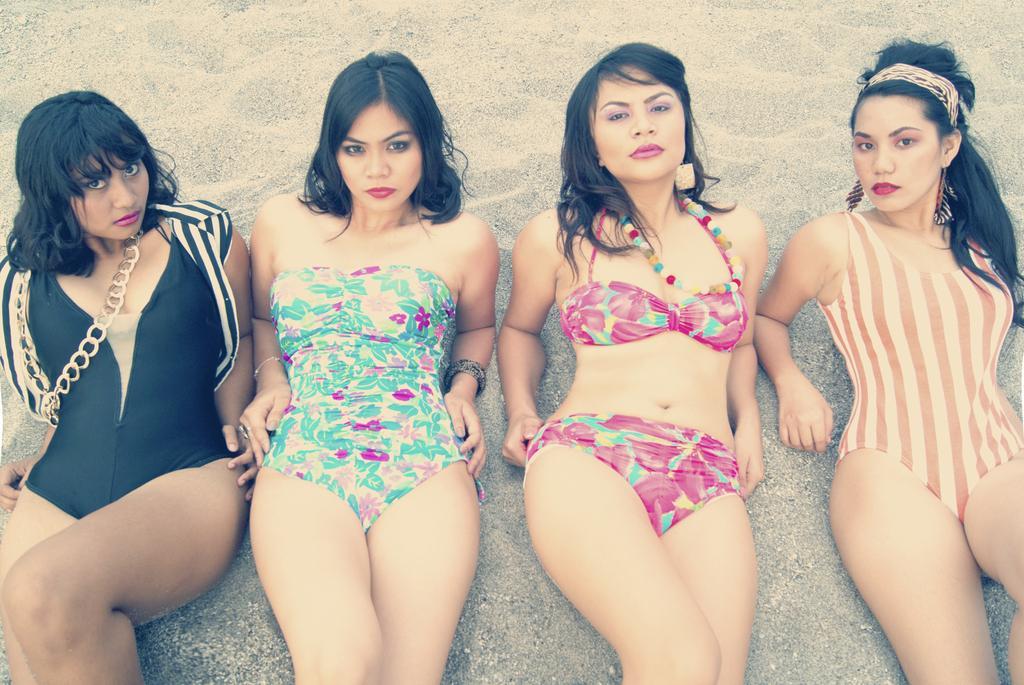How would you summarize this image in a sentence or two? Here in this picture we can see a group of women laying on the ground, which is fully covered with sand over there. 